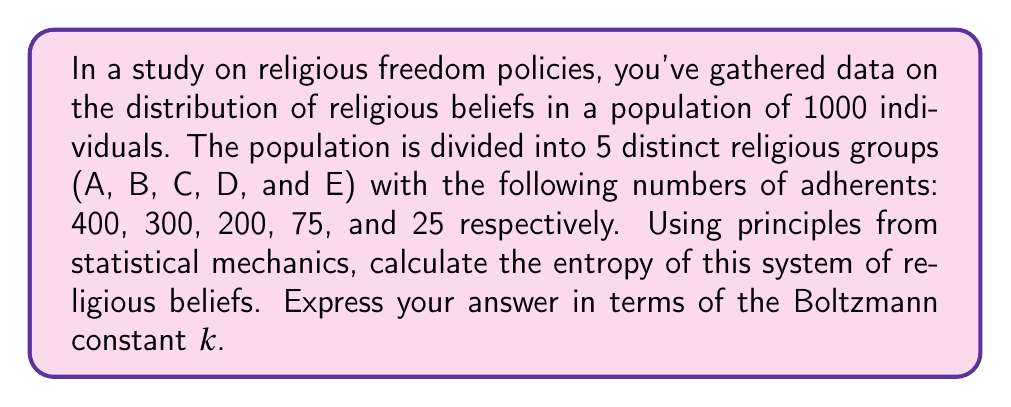What is the answer to this math problem? To calculate the entropy of this system using statistical mechanics principles, we'll follow these steps:

1) In statistical mechanics, entropy $S$ is given by the Boltzmann formula:

   $$S = k \ln W$$

   where $k$ is the Boltzmann constant and $W$ is the number of microstates.

2) In this case, we can consider each individual's religious belief as a microstate. The number of ways to distribute the individuals among the religious groups is given by the multinomial coefficient:

   $$W = \frac{N!}{n_A! n_B! n_C! n_D! n_E!}$$

   where $N$ is the total population and $n_i$ is the number of adherents in each group.

3) Substituting the given values:

   $$W = \frac{1000!}{400! 300! 200! 75! 25!}$$

4) Taking the natural logarithm and multiplying by $k$:

   $$S = k \ln \left(\frac{1000!}{400! 300! 200! 75! 25!}\right)$$

5) Using Stirling's approximation for large factorials ($\ln N! \approx N \ln N - N$):

   $$\begin{align}
   S &\approx k \left[(1000 \ln 1000 - 1000) - (400 \ln 400 - 400) - (300 \ln 300 - 300) \right. \\
   &\left. - (200 \ln 200 - 200) - (75 \ln 75 - 75) - (25 \ln 25 - 25)\right]
   \end{align}$$

6) Simplifying:

   $$S \approx k \left[1000 \ln 1000 - 400 \ln 400 - 300 \ln 300 - 200 \ln 200 - 75 \ln 75 - 25 \ln 25\right]$$

7) Calculating the numerical values:

   $$S \approx k \left[6907.76 - 2390.10 - 1704.33 - 1060.21 - 325.45 - 80.47\right]$$

8) Final result:

   $$S \approx 1347.20k$$
Answer: $1347.20k$ 